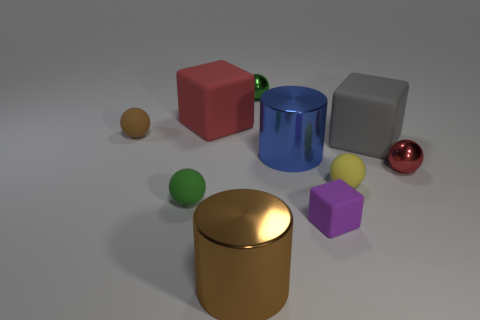There is a small green object that is behind the green matte ball; is it the same shape as the tiny green thing that is in front of the small yellow rubber object?
Your answer should be compact. Yes. Is the number of tiny metal things in front of the tiny green shiny ball the same as the number of large blue metallic cylinders?
Keep it short and to the point. Yes. What number of objects are made of the same material as the gray cube?
Give a very brief answer. 5. The small cube that is made of the same material as the small yellow sphere is what color?
Your answer should be very brief. Purple. There is a red block; is it the same size as the metal sphere in front of the gray matte cube?
Your answer should be very brief. No. What shape is the gray matte thing?
Your answer should be very brief. Cube. The other large matte object that is the same shape as the large gray rubber object is what color?
Keep it short and to the point. Red. What number of blue things are behind the shiny sphere that is on the right side of the big blue shiny cylinder?
Your answer should be compact. 1. How many blocks are green rubber objects or yellow matte things?
Make the answer very short. 0. Are there any large green cubes?
Offer a terse response. No. 